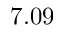Convert formula to latex. <formula><loc_0><loc_0><loc_500><loc_500>7 . 0 9</formula> 